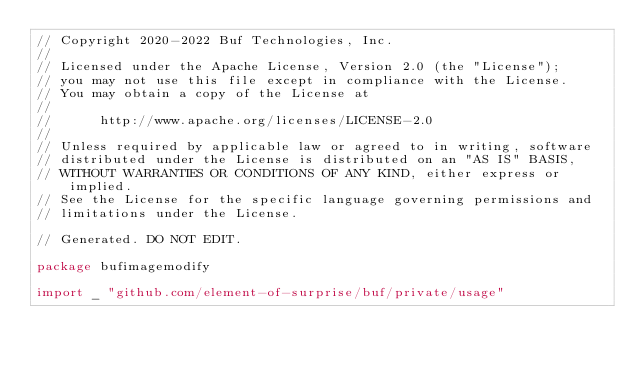<code> <loc_0><loc_0><loc_500><loc_500><_Go_>// Copyright 2020-2022 Buf Technologies, Inc.
//
// Licensed under the Apache License, Version 2.0 (the "License");
// you may not use this file except in compliance with the License.
// You may obtain a copy of the License at
//
//      http://www.apache.org/licenses/LICENSE-2.0
//
// Unless required by applicable law or agreed to in writing, software
// distributed under the License is distributed on an "AS IS" BASIS,
// WITHOUT WARRANTIES OR CONDITIONS OF ANY KIND, either express or implied.
// See the License for the specific language governing permissions and
// limitations under the License.

// Generated. DO NOT EDIT.

package bufimagemodify

import _ "github.com/element-of-surprise/buf/private/usage"
</code> 